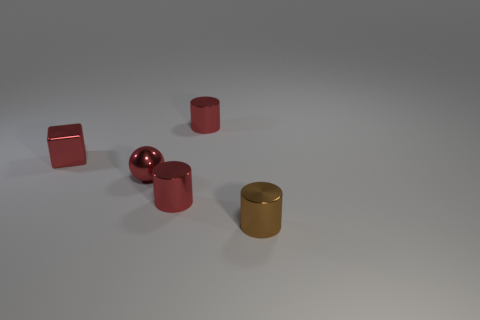Is the number of small objects in front of the small red ball less than the number of tiny metal objects?
Give a very brief answer. Yes. Is the number of small red shiny cylinders that are in front of the small brown cylinder greater than the number of tiny red shiny blocks in front of the red metal ball?
Offer a very short reply. No. What material is the thing that is behind the red metal block?
Offer a very short reply. Metal. Is the block the same color as the tiny metallic sphere?
Make the answer very short. Yes. What is the shape of the small red metallic thing on the left side of the small sphere behind the small red metal cylinder in front of the tiny red metal block?
Offer a terse response. Cube. How many things are red objects behind the tiny block or shiny cylinders that are behind the tiny red sphere?
Offer a terse response. 1. There is a red metal cylinder that is to the right of the red shiny cylinder in front of the small red metallic sphere; how big is it?
Make the answer very short. Small. Is the color of the metallic thing that is left of the tiny ball the same as the sphere?
Make the answer very short. Yes. Are there any other shiny objects of the same shape as the small brown metallic object?
Make the answer very short. Yes. There is a cube that is the same size as the ball; what is its color?
Give a very brief answer. Red. 